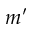Convert formula to latex. <formula><loc_0><loc_0><loc_500><loc_500>m ^ { \prime }</formula> 